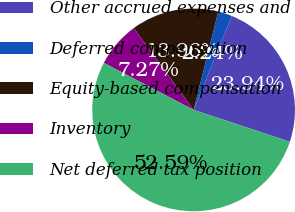Convert chart to OTSL. <chart><loc_0><loc_0><loc_500><loc_500><pie_chart><fcel>Other accrued expenses and<fcel>Deferred compensation<fcel>Equity-based compensation<fcel>Inventory<fcel>Net deferred tax position<nl><fcel>23.94%<fcel>2.24%<fcel>13.96%<fcel>7.27%<fcel>52.58%<nl></chart> 